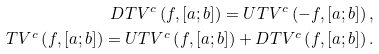<formula> <loc_0><loc_0><loc_500><loc_500>D T V ^ { c } \left ( f , \left [ a ; b \right ] \right ) = U T V ^ { c } \left ( - f , \left [ a ; b \right ] \right ) , \\ T V ^ { c } \left ( f , \left [ a ; b \right ] \right ) = U T V ^ { c } \left ( f , \left [ a ; b \right ] \right ) + D T V ^ { c } \left ( f , \left [ a ; b \right ] \right ) .</formula> 